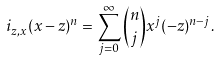<formula> <loc_0><loc_0><loc_500><loc_500>i _ { z , x } ( x - z ) ^ { n } = \sum _ { j = 0 } ^ { \infty } \binom { n } { j } x ^ { j } ( - z ) ^ { n - j } .</formula> 